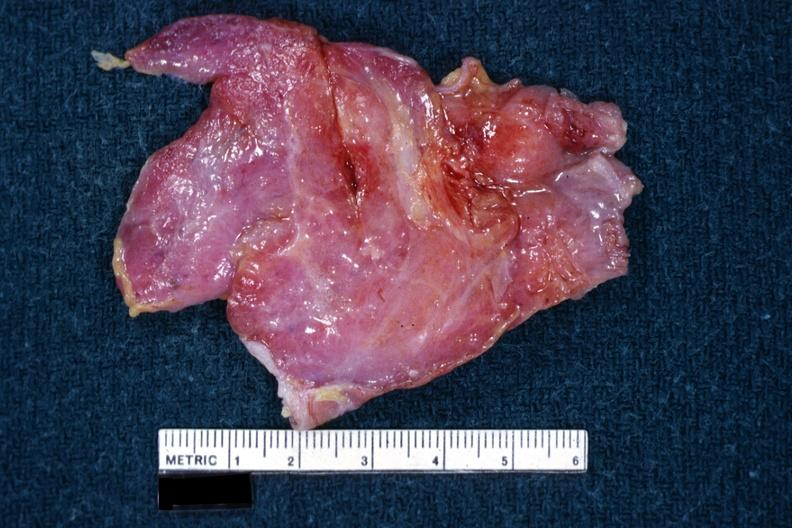what is present?
Answer the question using a single word or phrase. Hematologic 